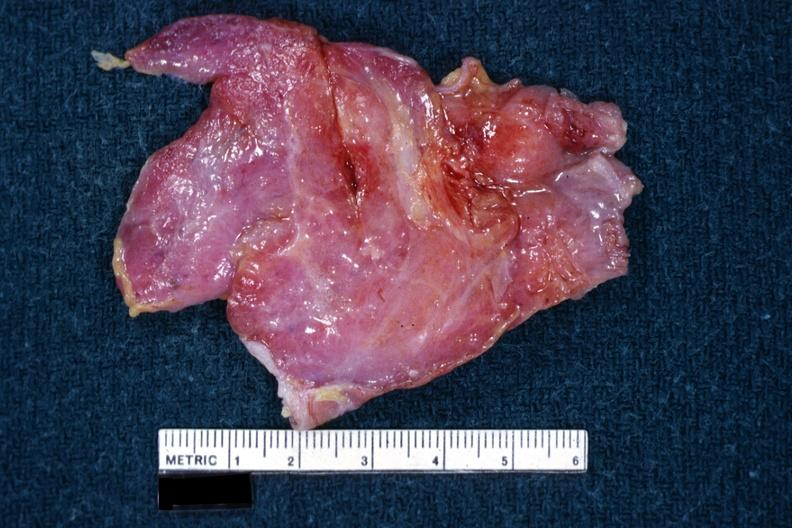what is present?
Answer the question using a single word or phrase. Hematologic 